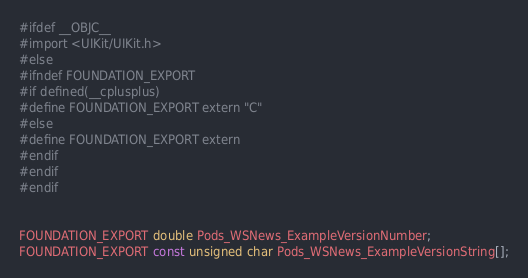Convert code to text. <code><loc_0><loc_0><loc_500><loc_500><_C_>#ifdef __OBJC__
#import <UIKit/UIKit.h>
#else
#ifndef FOUNDATION_EXPORT
#if defined(__cplusplus)
#define FOUNDATION_EXPORT extern "C"
#else
#define FOUNDATION_EXPORT extern
#endif
#endif
#endif


FOUNDATION_EXPORT double Pods_WSNews_ExampleVersionNumber;
FOUNDATION_EXPORT const unsigned char Pods_WSNews_ExampleVersionString[];

</code> 